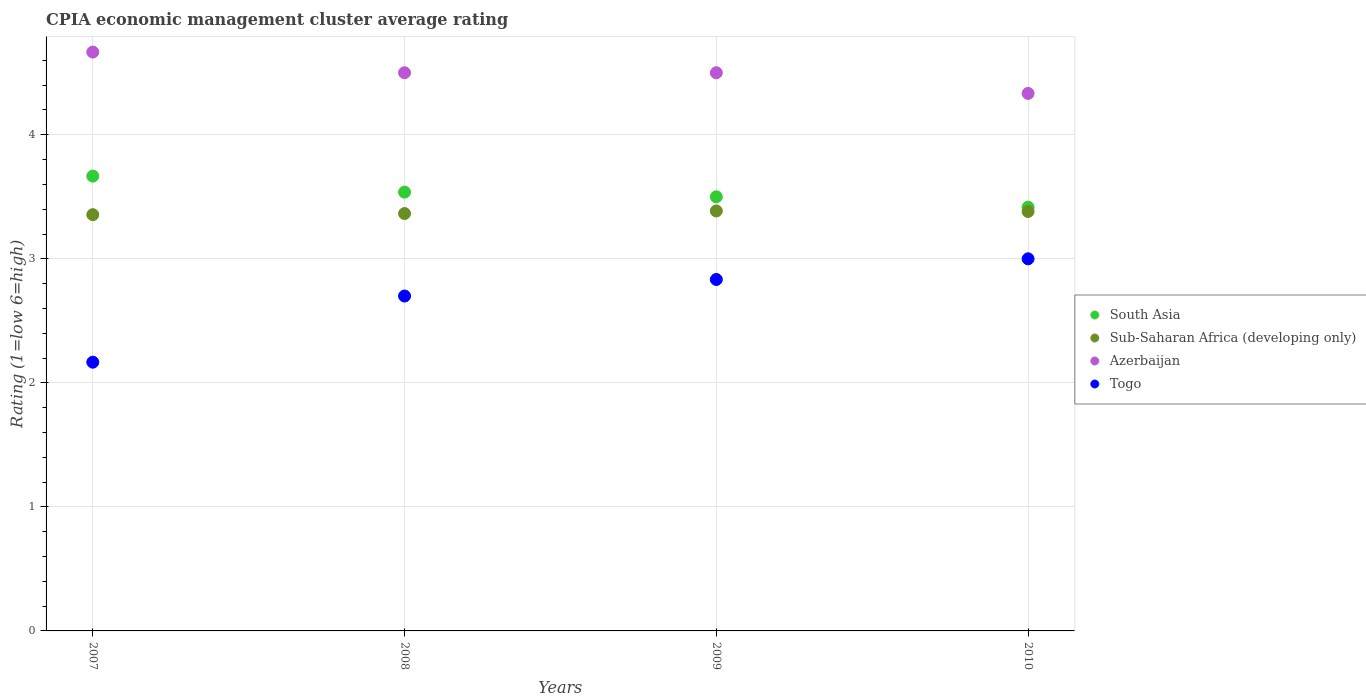Is the number of dotlines equal to the number of legend labels?
Give a very brief answer. Yes. Across all years, what is the maximum CPIA rating in South Asia?
Offer a very short reply. 3.67. Across all years, what is the minimum CPIA rating in Sub-Saharan Africa (developing only)?
Your response must be concise. 3.36. In which year was the CPIA rating in Azerbaijan maximum?
Offer a terse response. 2007. What is the total CPIA rating in Azerbaijan in the graph?
Offer a terse response. 18. What is the difference between the CPIA rating in Togo in 2007 and that in 2010?
Offer a terse response. -0.83. What is the difference between the CPIA rating in Togo in 2008 and the CPIA rating in Azerbaijan in 2009?
Your response must be concise. -1.8. What is the average CPIA rating in Sub-Saharan Africa (developing only) per year?
Offer a very short reply. 3.37. In the year 2008, what is the difference between the CPIA rating in Togo and CPIA rating in Azerbaijan?
Give a very brief answer. -1.8. What is the ratio of the CPIA rating in Togo in 2007 to that in 2009?
Your response must be concise. 0.76. Is the CPIA rating in Sub-Saharan Africa (developing only) in 2008 less than that in 2010?
Offer a very short reply. Yes. Is the difference between the CPIA rating in Togo in 2007 and 2008 greater than the difference between the CPIA rating in Azerbaijan in 2007 and 2008?
Give a very brief answer. No. What is the difference between the highest and the second highest CPIA rating in South Asia?
Provide a short and direct response. 0.13. What is the difference between the highest and the lowest CPIA rating in Togo?
Give a very brief answer. 0.83. Is the sum of the CPIA rating in Togo in 2007 and 2008 greater than the maximum CPIA rating in South Asia across all years?
Offer a very short reply. Yes. Is it the case that in every year, the sum of the CPIA rating in Azerbaijan and CPIA rating in Togo  is greater than the sum of CPIA rating in South Asia and CPIA rating in Sub-Saharan Africa (developing only)?
Your response must be concise. No. Is it the case that in every year, the sum of the CPIA rating in Azerbaijan and CPIA rating in Togo  is greater than the CPIA rating in Sub-Saharan Africa (developing only)?
Offer a very short reply. Yes. Does the CPIA rating in Togo monotonically increase over the years?
Give a very brief answer. Yes. How many years are there in the graph?
Provide a succinct answer. 4. What is the difference between two consecutive major ticks on the Y-axis?
Keep it short and to the point. 1. Does the graph contain any zero values?
Make the answer very short. No. Where does the legend appear in the graph?
Give a very brief answer. Center right. How many legend labels are there?
Your answer should be compact. 4. How are the legend labels stacked?
Offer a very short reply. Vertical. What is the title of the graph?
Ensure brevity in your answer.  CPIA economic management cluster average rating. Does "Cote d'Ivoire" appear as one of the legend labels in the graph?
Offer a terse response. No. What is the label or title of the X-axis?
Offer a terse response. Years. What is the Rating (1=low 6=high) in South Asia in 2007?
Keep it short and to the point. 3.67. What is the Rating (1=low 6=high) of Sub-Saharan Africa (developing only) in 2007?
Give a very brief answer. 3.36. What is the Rating (1=low 6=high) in Azerbaijan in 2007?
Provide a short and direct response. 4.67. What is the Rating (1=low 6=high) of Togo in 2007?
Ensure brevity in your answer.  2.17. What is the Rating (1=low 6=high) of South Asia in 2008?
Your answer should be compact. 3.54. What is the Rating (1=low 6=high) of Sub-Saharan Africa (developing only) in 2008?
Offer a terse response. 3.36. What is the Rating (1=low 6=high) in Togo in 2008?
Make the answer very short. 2.7. What is the Rating (1=low 6=high) of Sub-Saharan Africa (developing only) in 2009?
Your answer should be very brief. 3.39. What is the Rating (1=low 6=high) in Togo in 2009?
Ensure brevity in your answer.  2.83. What is the Rating (1=low 6=high) of South Asia in 2010?
Give a very brief answer. 3.42. What is the Rating (1=low 6=high) in Sub-Saharan Africa (developing only) in 2010?
Make the answer very short. 3.38. What is the Rating (1=low 6=high) of Azerbaijan in 2010?
Ensure brevity in your answer.  4.33. What is the Rating (1=low 6=high) of Togo in 2010?
Keep it short and to the point. 3. Across all years, what is the maximum Rating (1=low 6=high) in South Asia?
Offer a very short reply. 3.67. Across all years, what is the maximum Rating (1=low 6=high) in Sub-Saharan Africa (developing only)?
Make the answer very short. 3.39. Across all years, what is the maximum Rating (1=low 6=high) of Azerbaijan?
Ensure brevity in your answer.  4.67. Across all years, what is the maximum Rating (1=low 6=high) of Togo?
Your answer should be very brief. 3. Across all years, what is the minimum Rating (1=low 6=high) of South Asia?
Make the answer very short. 3.42. Across all years, what is the minimum Rating (1=low 6=high) in Sub-Saharan Africa (developing only)?
Your answer should be compact. 3.36. Across all years, what is the minimum Rating (1=low 6=high) in Azerbaijan?
Keep it short and to the point. 4.33. Across all years, what is the minimum Rating (1=low 6=high) in Togo?
Keep it short and to the point. 2.17. What is the total Rating (1=low 6=high) of South Asia in the graph?
Keep it short and to the point. 14.12. What is the total Rating (1=low 6=high) of Sub-Saharan Africa (developing only) in the graph?
Give a very brief answer. 13.49. What is the total Rating (1=low 6=high) of Azerbaijan in the graph?
Offer a very short reply. 18. What is the difference between the Rating (1=low 6=high) of South Asia in 2007 and that in 2008?
Your answer should be very brief. 0.13. What is the difference between the Rating (1=low 6=high) of Sub-Saharan Africa (developing only) in 2007 and that in 2008?
Offer a very short reply. -0.01. What is the difference between the Rating (1=low 6=high) in Togo in 2007 and that in 2008?
Make the answer very short. -0.53. What is the difference between the Rating (1=low 6=high) in Sub-Saharan Africa (developing only) in 2007 and that in 2009?
Your response must be concise. -0.03. What is the difference between the Rating (1=low 6=high) in Azerbaijan in 2007 and that in 2009?
Ensure brevity in your answer.  0.17. What is the difference between the Rating (1=low 6=high) in South Asia in 2007 and that in 2010?
Provide a short and direct response. 0.25. What is the difference between the Rating (1=low 6=high) in Sub-Saharan Africa (developing only) in 2007 and that in 2010?
Your response must be concise. -0.03. What is the difference between the Rating (1=low 6=high) of South Asia in 2008 and that in 2009?
Your answer should be very brief. 0.04. What is the difference between the Rating (1=low 6=high) of Sub-Saharan Africa (developing only) in 2008 and that in 2009?
Give a very brief answer. -0.02. What is the difference between the Rating (1=low 6=high) in Togo in 2008 and that in 2009?
Your response must be concise. -0.13. What is the difference between the Rating (1=low 6=high) of South Asia in 2008 and that in 2010?
Your answer should be very brief. 0.12. What is the difference between the Rating (1=low 6=high) in Sub-Saharan Africa (developing only) in 2008 and that in 2010?
Your answer should be compact. -0.02. What is the difference between the Rating (1=low 6=high) in Azerbaijan in 2008 and that in 2010?
Provide a succinct answer. 0.17. What is the difference between the Rating (1=low 6=high) in South Asia in 2009 and that in 2010?
Your response must be concise. 0.08. What is the difference between the Rating (1=low 6=high) of Sub-Saharan Africa (developing only) in 2009 and that in 2010?
Offer a very short reply. 0. What is the difference between the Rating (1=low 6=high) of Azerbaijan in 2009 and that in 2010?
Your answer should be compact. 0.17. What is the difference between the Rating (1=low 6=high) in Togo in 2009 and that in 2010?
Make the answer very short. -0.17. What is the difference between the Rating (1=low 6=high) of South Asia in 2007 and the Rating (1=low 6=high) of Sub-Saharan Africa (developing only) in 2008?
Keep it short and to the point. 0.3. What is the difference between the Rating (1=low 6=high) in South Asia in 2007 and the Rating (1=low 6=high) in Togo in 2008?
Keep it short and to the point. 0.97. What is the difference between the Rating (1=low 6=high) of Sub-Saharan Africa (developing only) in 2007 and the Rating (1=low 6=high) of Azerbaijan in 2008?
Offer a very short reply. -1.14. What is the difference between the Rating (1=low 6=high) in Sub-Saharan Africa (developing only) in 2007 and the Rating (1=low 6=high) in Togo in 2008?
Your answer should be compact. 0.66. What is the difference between the Rating (1=low 6=high) in Azerbaijan in 2007 and the Rating (1=low 6=high) in Togo in 2008?
Give a very brief answer. 1.97. What is the difference between the Rating (1=low 6=high) in South Asia in 2007 and the Rating (1=low 6=high) in Sub-Saharan Africa (developing only) in 2009?
Provide a short and direct response. 0.28. What is the difference between the Rating (1=low 6=high) of Sub-Saharan Africa (developing only) in 2007 and the Rating (1=low 6=high) of Azerbaijan in 2009?
Keep it short and to the point. -1.14. What is the difference between the Rating (1=low 6=high) in Sub-Saharan Africa (developing only) in 2007 and the Rating (1=low 6=high) in Togo in 2009?
Provide a short and direct response. 0.52. What is the difference between the Rating (1=low 6=high) of Azerbaijan in 2007 and the Rating (1=low 6=high) of Togo in 2009?
Offer a very short reply. 1.83. What is the difference between the Rating (1=low 6=high) of South Asia in 2007 and the Rating (1=low 6=high) of Sub-Saharan Africa (developing only) in 2010?
Make the answer very short. 0.29. What is the difference between the Rating (1=low 6=high) in Sub-Saharan Africa (developing only) in 2007 and the Rating (1=low 6=high) in Azerbaijan in 2010?
Make the answer very short. -0.98. What is the difference between the Rating (1=low 6=high) in Sub-Saharan Africa (developing only) in 2007 and the Rating (1=low 6=high) in Togo in 2010?
Ensure brevity in your answer.  0.36. What is the difference between the Rating (1=low 6=high) in South Asia in 2008 and the Rating (1=low 6=high) in Sub-Saharan Africa (developing only) in 2009?
Your answer should be compact. 0.15. What is the difference between the Rating (1=low 6=high) of South Asia in 2008 and the Rating (1=low 6=high) of Azerbaijan in 2009?
Ensure brevity in your answer.  -0.96. What is the difference between the Rating (1=low 6=high) in South Asia in 2008 and the Rating (1=low 6=high) in Togo in 2009?
Ensure brevity in your answer.  0.7. What is the difference between the Rating (1=low 6=high) in Sub-Saharan Africa (developing only) in 2008 and the Rating (1=low 6=high) in Azerbaijan in 2009?
Make the answer very short. -1.14. What is the difference between the Rating (1=low 6=high) of Sub-Saharan Africa (developing only) in 2008 and the Rating (1=low 6=high) of Togo in 2009?
Ensure brevity in your answer.  0.53. What is the difference between the Rating (1=low 6=high) in South Asia in 2008 and the Rating (1=low 6=high) in Sub-Saharan Africa (developing only) in 2010?
Keep it short and to the point. 0.16. What is the difference between the Rating (1=low 6=high) in South Asia in 2008 and the Rating (1=low 6=high) in Azerbaijan in 2010?
Keep it short and to the point. -0.8. What is the difference between the Rating (1=low 6=high) in South Asia in 2008 and the Rating (1=low 6=high) in Togo in 2010?
Give a very brief answer. 0.54. What is the difference between the Rating (1=low 6=high) of Sub-Saharan Africa (developing only) in 2008 and the Rating (1=low 6=high) of Azerbaijan in 2010?
Your answer should be very brief. -0.97. What is the difference between the Rating (1=low 6=high) in Sub-Saharan Africa (developing only) in 2008 and the Rating (1=low 6=high) in Togo in 2010?
Your response must be concise. 0.36. What is the difference between the Rating (1=low 6=high) of South Asia in 2009 and the Rating (1=low 6=high) of Sub-Saharan Africa (developing only) in 2010?
Provide a short and direct response. 0.12. What is the difference between the Rating (1=low 6=high) of Sub-Saharan Africa (developing only) in 2009 and the Rating (1=low 6=high) of Azerbaijan in 2010?
Make the answer very short. -0.95. What is the difference between the Rating (1=low 6=high) of Sub-Saharan Africa (developing only) in 2009 and the Rating (1=low 6=high) of Togo in 2010?
Give a very brief answer. 0.39. What is the difference between the Rating (1=low 6=high) of Azerbaijan in 2009 and the Rating (1=low 6=high) of Togo in 2010?
Keep it short and to the point. 1.5. What is the average Rating (1=low 6=high) of South Asia per year?
Offer a terse response. 3.53. What is the average Rating (1=low 6=high) of Sub-Saharan Africa (developing only) per year?
Offer a very short reply. 3.37. What is the average Rating (1=low 6=high) in Togo per year?
Provide a short and direct response. 2.67. In the year 2007, what is the difference between the Rating (1=low 6=high) of South Asia and Rating (1=low 6=high) of Sub-Saharan Africa (developing only)?
Your answer should be compact. 0.31. In the year 2007, what is the difference between the Rating (1=low 6=high) in South Asia and Rating (1=low 6=high) in Azerbaijan?
Your answer should be very brief. -1. In the year 2007, what is the difference between the Rating (1=low 6=high) in South Asia and Rating (1=low 6=high) in Togo?
Provide a succinct answer. 1.5. In the year 2007, what is the difference between the Rating (1=low 6=high) in Sub-Saharan Africa (developing only) and Rating (1=low 6=high) in Azerbaijan?
Provide a short and direct response. -1.31. In the year 2007, what is the difference between the Rating (1=low 6=high) of Sub-Saharan Africa (developing only) and Rating (1=low 6=high) of Togo?
Give a very brief answer. 1.19. In the year 2008, what is the difference between the Rating (1=low 6=high) in South Asia and Rating (1=low 6=high) in Sub-Saharan Africa (developing only)?
Make the answer very short. 0.17. In the year 2008, what is the difference between the Rating (1=low 6=high) of South Asia and Rating (1=low 6=high) of Azerbaijan?
Give a very brief answer. -0.96. In the year 2008, what is the difference between the Rating (1=low 6=high) in South Asia and Rating (1=low 6=high) in Togo?
Provide a succinct answer. 0.84. In the year 2008, what is the difference between the Rating (1=low 6=high) of Sub-Saharan Africa (developing only) and Rating (1=low 6=high) of Azerbaijan?
Keep it short and to the point. -1.14. In the year 2008, what is the difference between the Rating (1=low 6=high) of Sub-Saharan Africa (developing only) and Rating (1=low 6=high) of Togo?
Offer a terse response. 0.66. In the year 2008, what is the difference between the Rating (1=low 6=high) in Azerbaijan and Rating (1=low 6=high) in Togo?
Make the answer very short. 1.8. In the year 2009, what is the difference between the Rating (1=low 6=high) of South Asia and Rating (1=low 6=high) of Sub-Saharan Africa (developing only)?
Ensure brevity in your answer.  0.11. In the year 2009, what is the difference between the Rating (1=low 6=high) of South Asia and Rating (1=low 6=high) of Togo?
Give a very brief answer. 0.67. In the year 2009, what is the difference between the Rating (1=low 6=high) of Sub-Saharan Africa (developing only) and Rating (1=low 6=high) of Azerbaijan?
Your answer should be very brief. -1.11. In the year 2009, what is the difference between the Rating (1=low 6=high) in Sub-Saharan Africa (developing only) and Rating (1=low 6=high) in Togo?
Keep it short and to the point. 0.55. In the year 2010, what is the difference between the Rating (1=low 6=high) of South Asia and Rating (1=low 6=high) of Sub-Saharan Africa (developing only)?
Your answer should be very brief. 0.04. In the year 2010, what is the difference between the Rating (1=low 6=high) in South Asia and Rating (1=low 6=high) in Azerbaijan?
Give a very brief answer. -0.92. In the year 2010, what is the difference between the Rating (1=low 6=high) of South Asia and Rating (1=low 6=high) of Togo?
Your response must be concise. 0.42. In the year 2010, what is the difference between the Rating (1=low 6=high) of Sub-Saharan Africa (developing only) and Rating (1=low 6=high) of Azerbaijan?
Keep it short and to the point. -0.95. In the year 2010, what is the difference between the Rating (1=low 6=high) of Sub-Saharan Africa (developing only) and Rating (1=low 6=high) of Togo?
Offer a very short reply. 0.38. What is the ratio of the Rating (1=low 6=high) in South Asia in 2007 to that in 2008?
Your response must be concise. 1.04. What is the ratio of the Rating (1=low 6=high) in Azerbaijan in 2007 to that in 2008?
Your response must be concise. 1.04. What is the ratio of the Rating (1=low 6=high) in Togo in 2007 to that in 2008?
Provide a short and direct response. 0.8. What is the ratio of the Rating (1=low 6=high) in South Asia in 2007 to that in 2009?
Offer a very short reply. 1.05. What is the ratio of the Rating (1=low 6=high) of Sub-Saharan Africa (developing only) in 2007 to that in 2009?
Your answer should be compact. 0.99. What is the ratio of the Rating (1=low 6=high) in Togo in 2007 to that in 2009?
Your answer should be very brief. 0.76. What is the ratio of the Rating (1=low 6=high) in South Asia in 2007 to that in 2010?
Make the answer very short. 1.07. What is the ratio of the Rating (1=low 6=high) in Azerbaijan in 2007 to that in 2010?
Keep it short and to the point. 1.08. What is the ratio of the Rating (1=low 6=high) of Togo in 2007 to that in 2010?
Give a very brief answer. 0.72. What is the ratio of the Rating (1=low 6=high) in South Asia in 2008 to that in 2009?
Provide a succinct answer. 1.01. What is the ratio of the Rating (1=low 6=high) in Sub-Saharan Africa (developing only) in 2008 to that in 2009?
Your answer should be very brief. 0.99. What is the ratio of the Rating (1=low 6=high) of Azerbaijan in 2008 to that in 2009?
Provide a succinct answer. 1. What is the ratio of the Rating (1=low 6=high) in Togo in 2008 to that in 2009?
Your answer should be compact. 0.95. What is the ratio of the Rating (1=low 6=high) of South Asia in 2008 to that in 2010?
Make the answer very short. 1.04. What is the ratio of the Rating (1=low 6=high) in Azerbaijan in 2008 to that in 2010?
Your answer should be compact. 1.04. What is the ratio of the Rating (1=low 6=high) of Togo in 2008 to that in 2010?
Provide a short and direct response. 0.9. What is the ratio of the Rating (1=low 6=high) in South Asia in 2009 to that in 2010?
Give a very brief answer. 1.02. What is the ratio of the Rating (1=low 6=high) of Azerbaijan in 2009 to that in 2010?
Give a very brief answer. 1.04. What is the ratio of the Rating (1=low 6=high) in Togo in 2009 to that in 2010?
Your response must be concise. 0.94. What is the difference between the highest and the second highest Rating (1=low 6=high) in South Asia?
Ensure brevity in your answer.  0.13. What is the difference between the highest and the second highest Rating (1=low 6=high) of Sub-Saharan Africa (developing only)?
Keep it short and to the point. 0. What is the difference between the highest and the second highest Rating (1=low 6=high) of Azerbaijan?
Keep it short and to the point. 0.17. What is the difference between the highest and the second highest Rating (1=low 6=high) in Togo?
Keep it short and to the point. 0.17. What is the difference between the highest and the lowest Rating (1=low 6=high) in Sub-Saharan Africa (developing only)?
Provide a succinct answer. 0.03. 